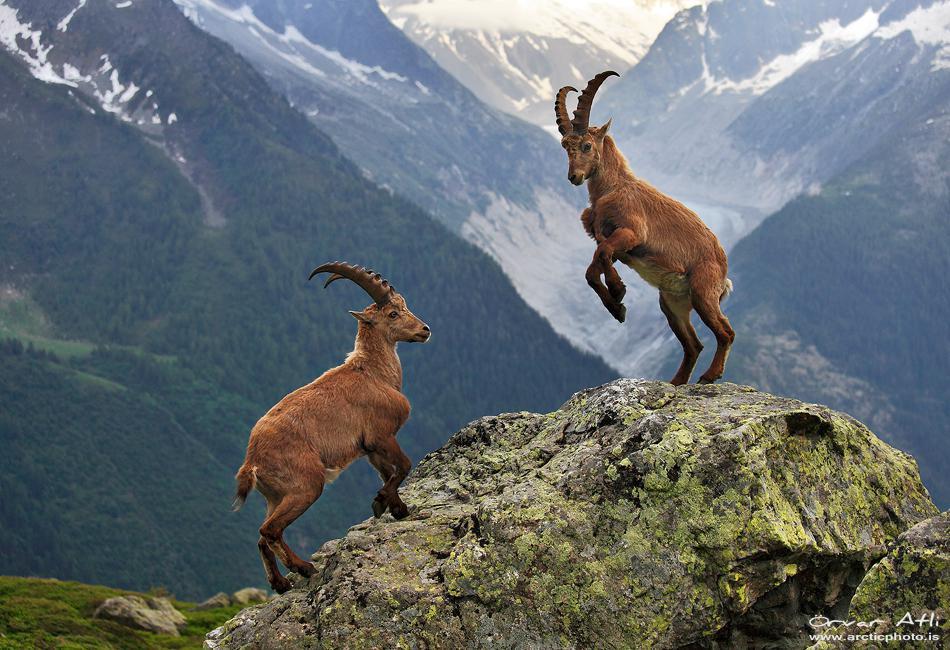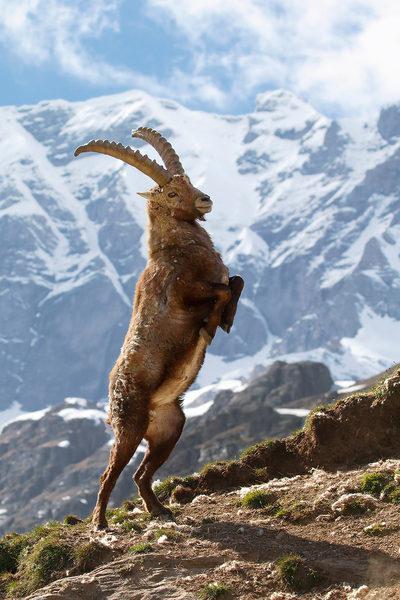The first image is the image on the left, the second image is the image on the right. Considering the images on both sides, is "One image contains one hooved animal with short horns, which is standing on some platform with its body turned leftward." valid? Answer yes or no. No. The first image is the image on the left, the second image is the image on the right. Considering the images on both sides, is "There are more rams in the image on the right than in the image on the left." valid? Answer yes or no. No. 